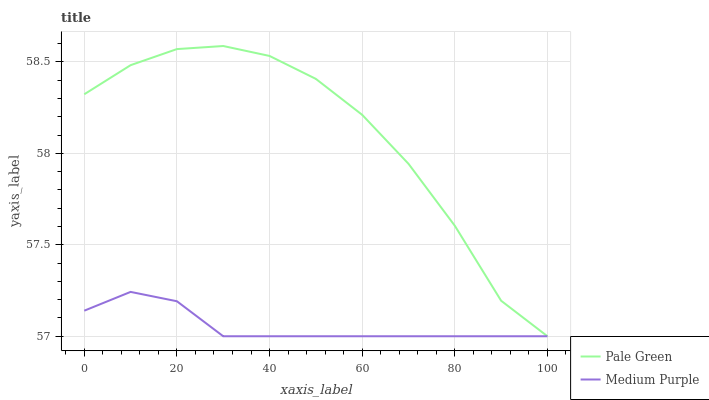Does Medium Purple have the minimum area under the curve?
Answer yes or no. Yes. Does Pale Green have the maximum area under the curve?
Answer yes or no. Yes. Does Pale Green have the minimum area under the curve?
Answer yes or no. No. Is Medium Purple the smoothest?
Answer yes or no. Yes. Is Pale Green the roughest?
Answer yes or no. Yes. Is Pale Green the smoothest?
Answer yes or no. No. 